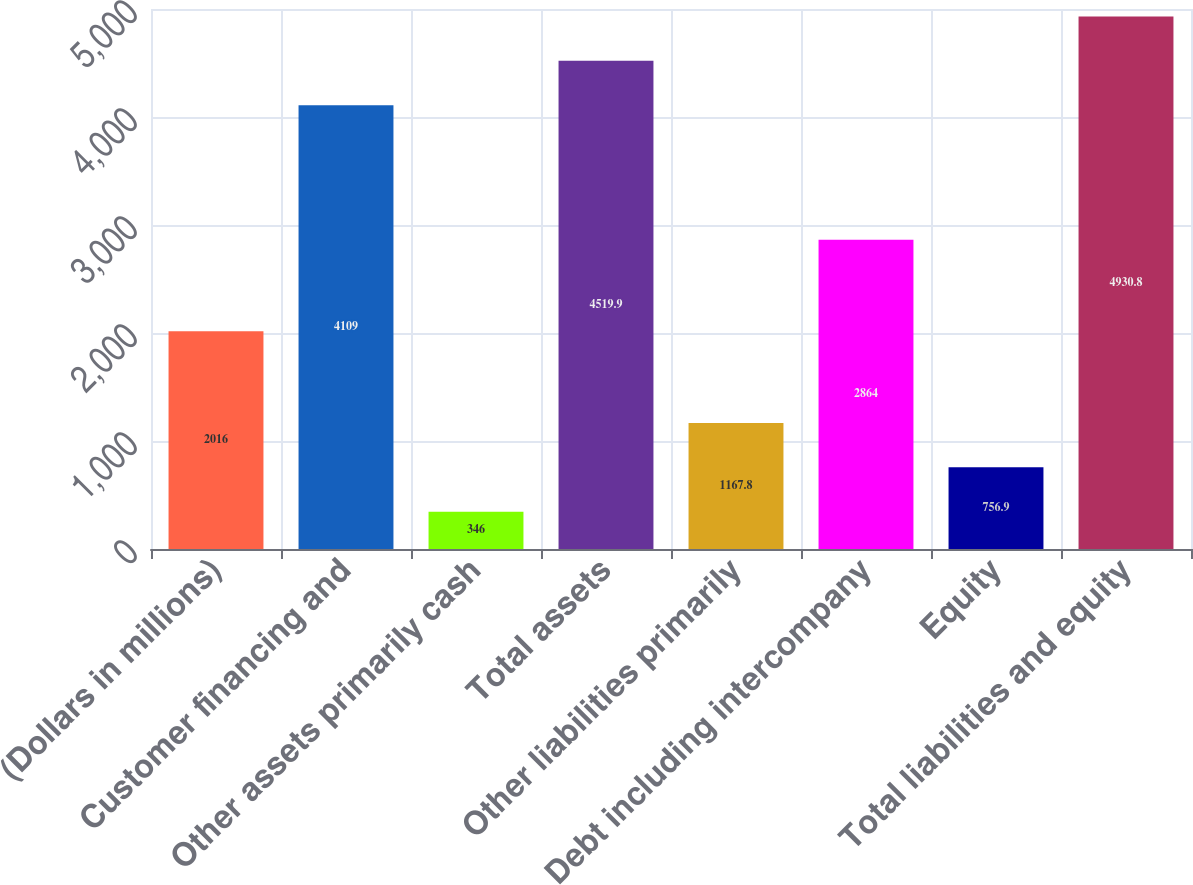Convert chart. <chart><loc_0><loc_0><loc_500><loc_500><bar_chart><fcel>(Dollars in millions)<fcel>Customer financing and<fcel>Other assets primarily cash<fcel>Total assets<fcel>Other liabilities primarily<fcel>Debt including intercompany<fcel>Equity<fcel>Total liabilities and equity<nl><fcel>2016<fcel>4109<fcel>346<fcel>4519.9<fcel>1167.8<fcel>2864<fcel>756.9<fcel>4930.8<nl></chart> 